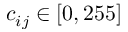<formula> <loc_0><loc_0><loc_500><loc_500>c _ { i j } \in \left [ 0 , 2 5 5 \right ]</formula> 